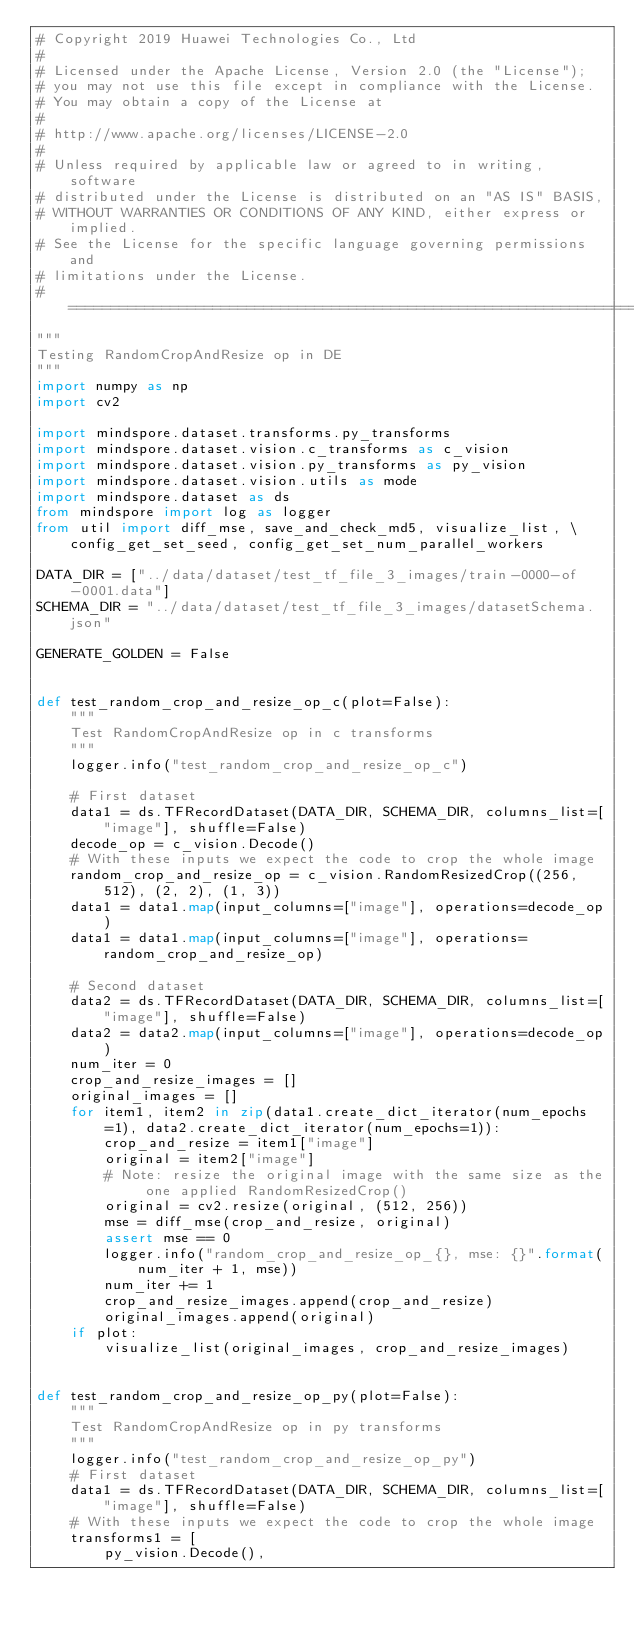<code> <loc_0><loc_0><loc_500><loc_500><_Python_># Copyright 2019 Huawei Technologies Co., Ltd
#
# Licensed under the Apache License, Version 2.0 (the "License");
# you may not use this file except in compliance with the License.
# You may obtain a copy of the License at
#
# http://www.apache.org/licenses/LICENSE-2.0
#
# Unless required by applicable law or agreed to in writing, software
# distributed under the License is distributed on an "AS IS" BASIS,
# WITHOUT WARRANTIES OR CONDITIONS OF ANY KIND, either express or implied.
# See the License for the specific language governing permissions and
# limitations under the License.
# ==============================================================================
"""
Testing RandomCropAndResize op in DE
"""
import numpy as np
import cv2

import mindspore.dataset.transforms.py_transforms
import mindspore.dataset.vision.c_transforms as c_vision
import mindspore.dataset.vision.py_transforms as py_vision
import mindspore.dataset.vision.utils as mode
import mindspore.dataset as ds
from mindspore import log as logger
from util import diff_mse, save_and_check_md5, visualize_list, \
    config_get_set_seed, config_get_set_num_parallel_workers

DATA_DIR = ["../data/dataset/test_tf_file_3_images/train-0000-of-0001.data"]
SCHEMA_DIR = "../data/dataset/test_tf_file_3_images/datasetSchema.json"

GENERATE_GOLDEN = False


def test_random_crop_and_resize_op_c(plot=False):
    """
    Test RandomCropAndResize op in c transforms
    """
    logger.info("test_random_crop_and_resize_op_c")

    # First dataset
    data1 = ds.TFRecordDataset(DATA_DIR, SCHEMA_DIR, columns_list=["image"], shuffle=False)
    decode_op = c_vision.Decode()
    # With these inputs we expect the code to crop the whole image
    random_crop_and_resize_op = c_vision.RandomResizedCrop((256, 512), (2, 2), (1, 3))
    data1 = data1.map(input_columns=["image"], operations=decode_op)
    data1 = data1.map(input_columns=["image"], operations=random_crop_and_resize_op)

    # Second dataset
    data2 = ds.TFRecordDataset(DATA_DIR, SCHEMA_DIR, columns_list=["image"], shuffle=False)
    data2 = data2.map(input_columns=["image"], operations=decode_op)
    num_iter = 0
    crop_and_resize_images = []
    original_images = []
    for item1, item2 in zip(data1.create_dict_iterator(num_epochs=1), data2.create_dict_iterator(num_epochs=1)):
        crop_and_resize = item1["image"]
        original = item2["image"]
        # Note: resize the original image with the same size as the one applied RandomResizedCrop()
        original = cv2.resize(original, (512, 256))
        mse = diff_mse(crop_and_resize, original)
        assert mse == 0
        logger.info("random_crop_and_resize_op_{}, mse: {}".format(num_iter + 1, mse))
        num_iter += 1
        crop_and_resize_images.append(crop_and_resize)
        original_images.append(original)
    if plot:
        visualize_list(original_images, crop_and_resize_images)


def test_random_crop_and_resize_op_py(plot=False):
    """
    Test RandomCropAndResize op in py transforms
    """
    logger.info("test_random_crop_and_resize_op_py")
    # First dataset
    data1 = ds.TFRecordDataset(DATA_DIR, SCHEMA_DIR, columns_list=["image"], shuffle=False)
    # With these inputs we expect the code to crop the whole image
    transforms1 = [
        py_vision.Decode(),</code> 